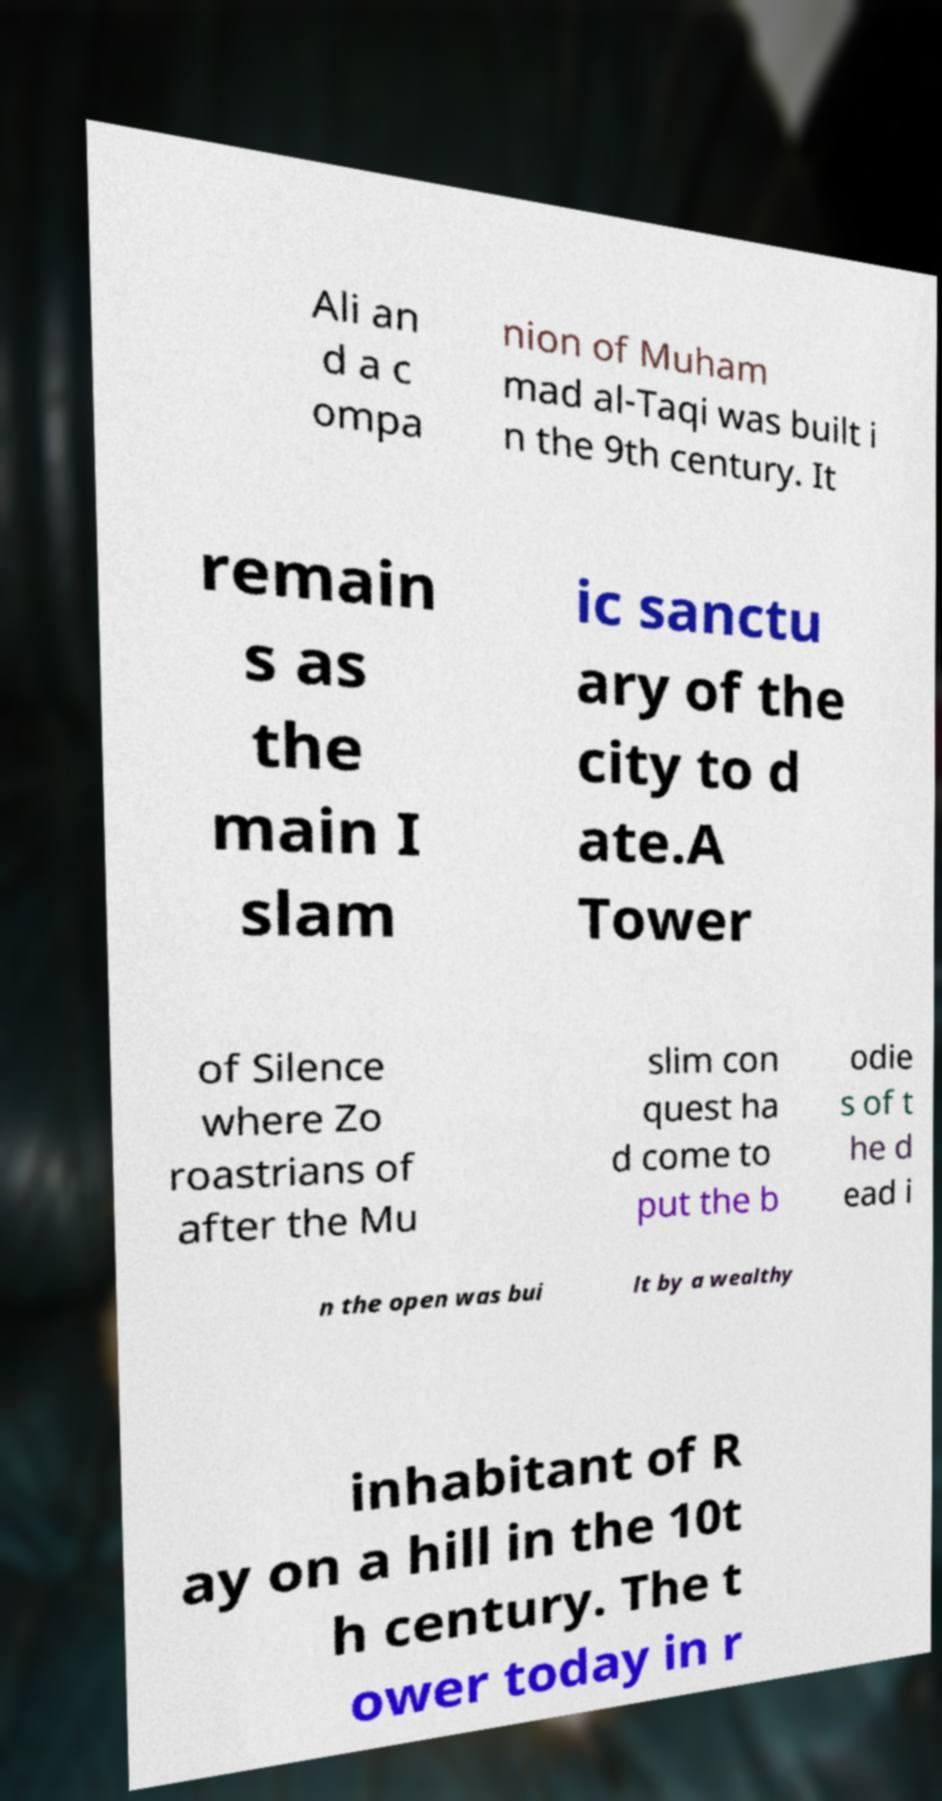There's text embedded in this image that I need extracted. Can you transcribe it verbatim? Ali an d a c ompa nion of Muham mad al-Taqi was built i n the 9th century. It remain s as the main I slam ic sanctu ary of the city to d ate.A Tower of Silence where Zo roastrians of after the Mu slim con quest ha d come to put the b odie s of t he d ead i n the open was bui lt by a wealthy inhabitant of R ay on a hill in the 10t h century. The t ower today in r 